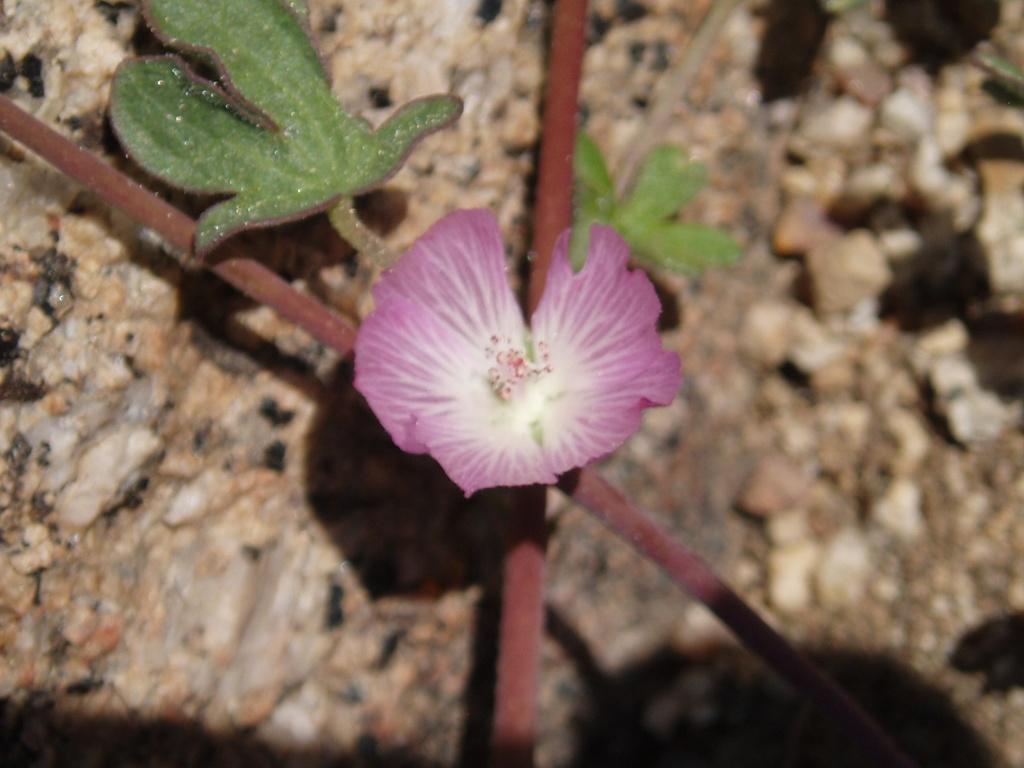Could you give a brief overview of what you see in this image? Here we can see a flower,leaves and stems. In the background there are stones. 